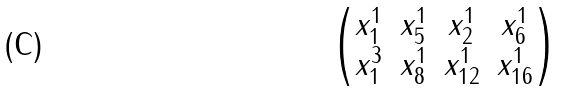Convert formula to latex. <formula><loc_0><loc_0><loc_500><loc_500>\begin{pmatrix} x _ { 1 } ^ { 1 } & x _ { 5 } ^ { 1 } & x _ { 2 } ^ { 1 } & x _ { 6 } ^ { 1 } \\ x _ { 1 } ^ { 3 } & x _ { 8 } ^ { 1 } & x _ { 1 2 } ^ { 1 } & x _ { 1 6 } ^ { 1 } \end{pmatrix}</formula> 